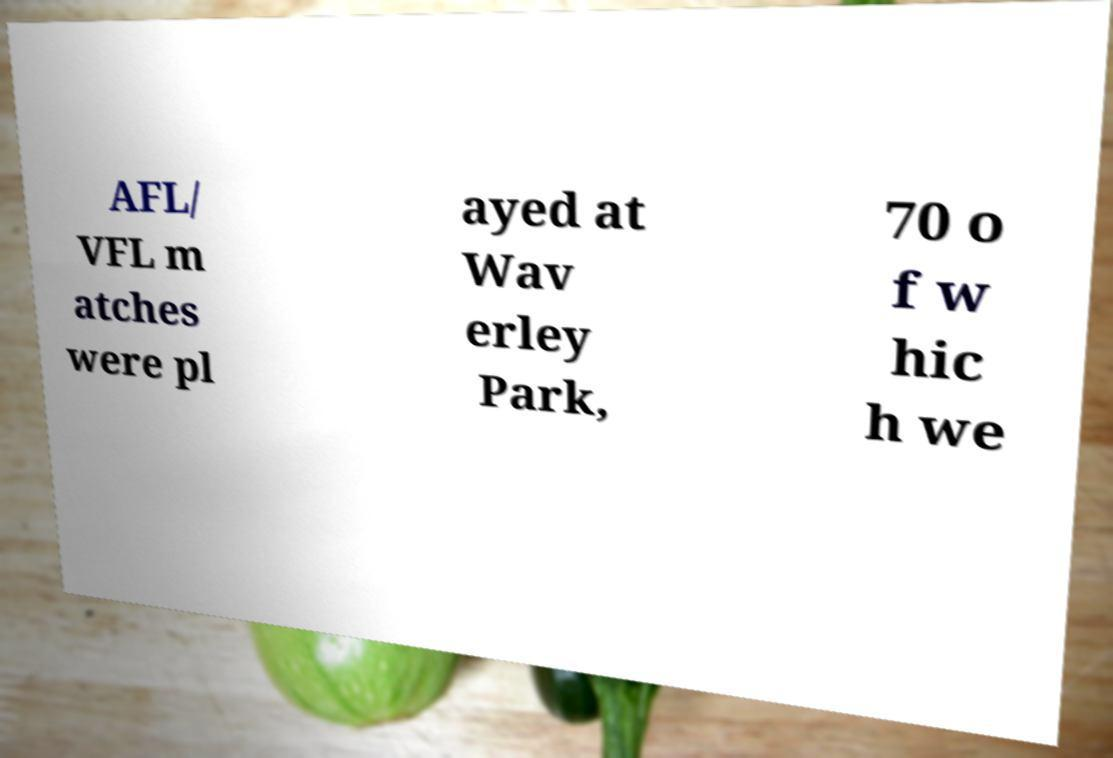There's text embedded in this image that I need extracted. Can you transcribe it verbatim? AFL/ VFL m atches were pl ayed at Wav erley Park, 70 o f w hic h we 